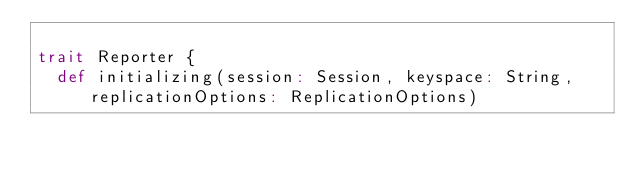Convert code to text. <code><loc_0><loc_0><loc_500><loc_500><_Scala_>
trait Reporter {
  def initializing(session: Session, keyspace: String, replicationOptions: ReplicationOptions)</code> 